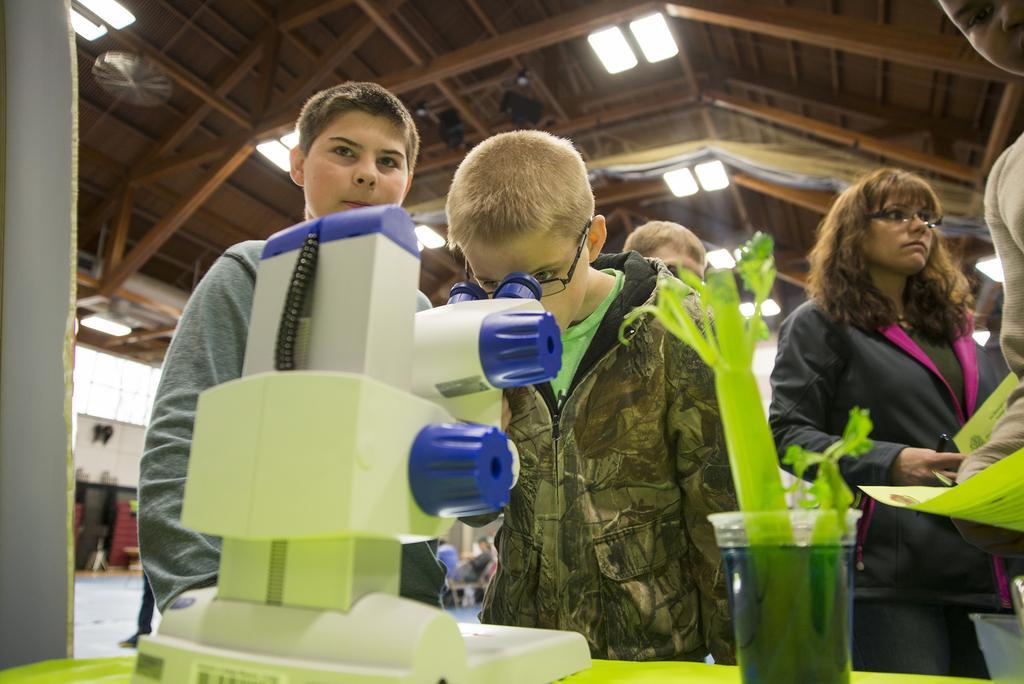Please provide a concise description of this image. In this picture there is a boy standing and looking into the microscope and there are group of people standing. In the foreground there is a microscope and there is a plant on the table. At the top there is a wooden roof and there are lights. At the back there are group of people sitting on the chairs. 